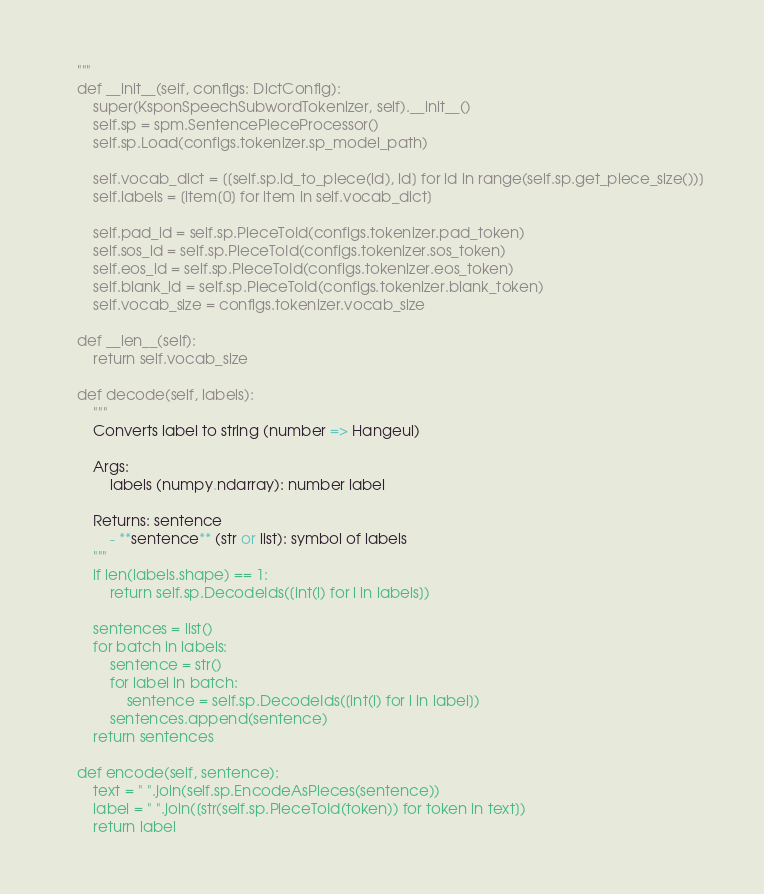<code> <loc_0><loc_0><loc_500><loc_500><_Python_>    """
    def __init__(self, configs: DictConfig):
        super(KsponSpeechSubwordTokenizer, self).__init__()
        self.sp = spm.SentencePieceProcessor()
        self.sp.Load(configs.tokenizer.sp_model_path)

        self.vocab_dict = [[self.sp.id_to_piece(id), id] for id in range(self.sp.get_piece_size())]
        self.labels = [item[0] for item in self.vocab_dict]

        self.pad_id = self.sp.PieceToId(configs.tokenizer.pad_token)
        self.sos_id = self.sp.PieceToId(configs.tokenizer.sos_token)
        self.eos_id = self.sp.PieceToId(configs.tokenizer.eos_token)
        self.blank_id = self.sp.PieceToId(configs.tokenizer.blank_token)
        self.vocab_size = configs.tokenizer.vocab_size

    def __len__(self):
        return self.vocab_size

    def decode(self, labels):
        """
        Converts label to string (number => Hangeul)

        Args:
            labels (numpy.ndarray): number label

        Returns: sentence
            - **sentence** (str or list): symbol of labels
        """
        if len(labels.shape) == 1:
            return self.sp.DecodeIds([int(l) for l in labels])

        sentences = list()
        for batch in labels:
            sentence = str()
            for label in batch:
                sentence = self.sp.DecodeIds([int(l) for l in label])
            sentences.append(sentence)
        return sentences

    def encode(self, sentence):
        text = " ".join(self.sp.EncodeAsPieces(sentence))
        label = " ".join([str(self.sp.PieceToId(token)) for token in text])
        return label

</code> 